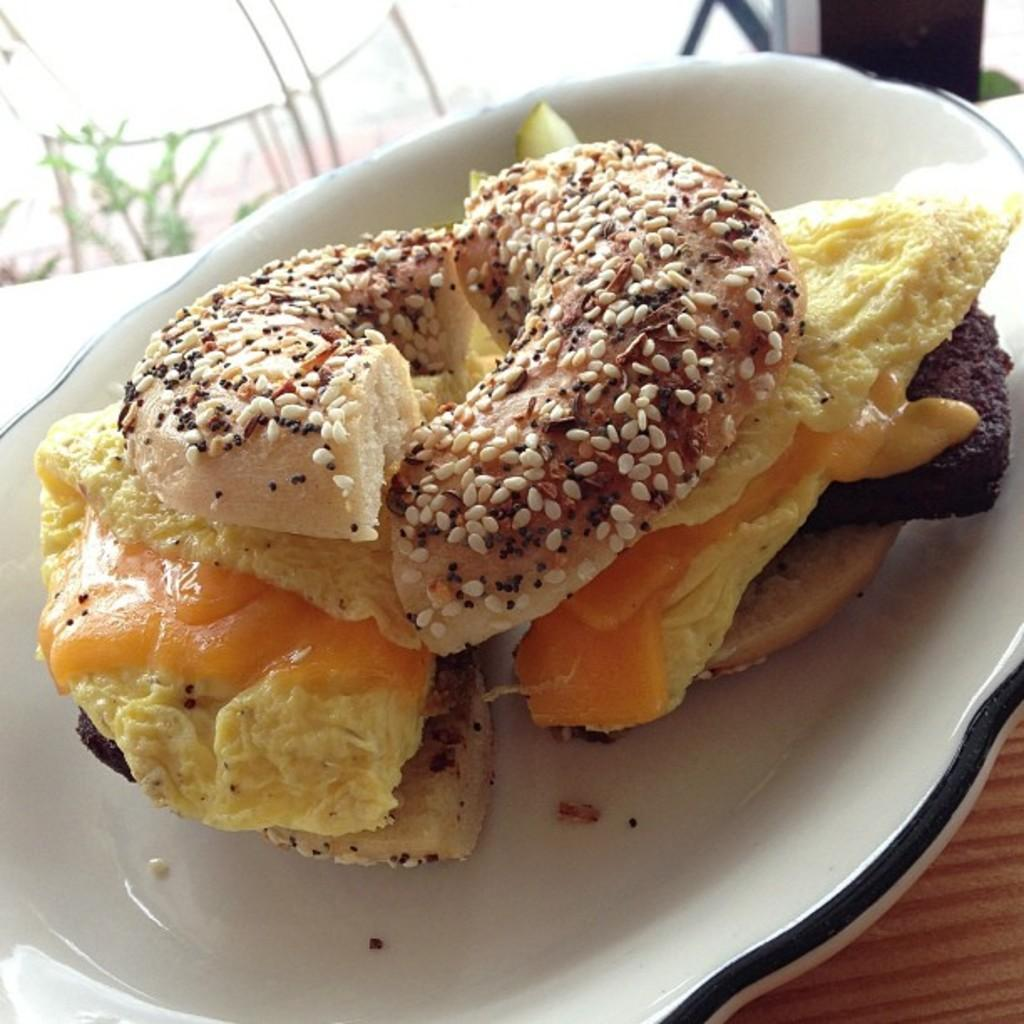What is on the plate in the image? There is an eatable item on a plate. Where is the plate located? The plate is placed on a table. What type of volcano can be seen erupting in the background of the image? There is no volcano present in the image; it only features an eatable item on a plate placed on a table. 